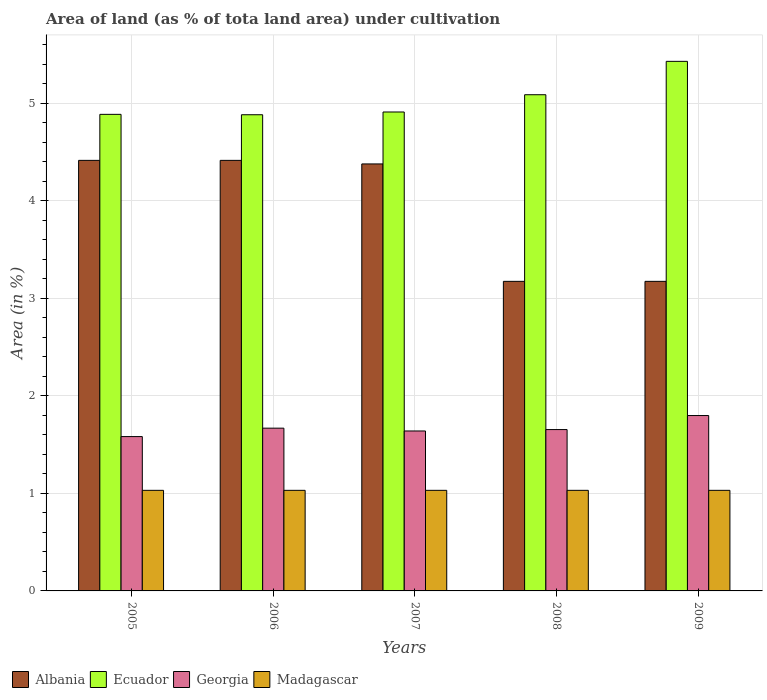How many different coloured bars are there?
Your answer should be very brief. 4. How many groups of bars are there?
Offer a terse response. 5. How many bars are there on the 5th tick from the left?
Your answer should be compact. 4. How many bars are there on the 1st tick from the right?
Your answer should be compact. 4. In how many cases, is the number of bars for a given year not equal to the number of legend labels?
Your answer should be very brief. 0. What is the percentage of land under cultivation in Georgia in 2009?
Offer a terse response. 1.8. Across all years, what is the maximum percentage of land under cultivation in Madagascar?
Ensure brevity in your answer.  1.03. Across all years, what is the minimum percentage of land under cultivation in Ecuador?
Ensure brevity in your answer.  4.88. In which year was the percentage of land under cultivation in Albania minimum?
Your answer should be compact. 2008. What is the total percentage of land under cultivation in Georgia in the graph?
Keep it short and to the point. 8.35. What is the difference between the percentage of land under cultivation in Albania in 2005 and that in 2009?
Give a very brief answer. 1.24. What is the difference between the percentage of land under cultivation in Georgia in 2009 and the percentage of land under cultivation in Albania in 2006?
Keep it short and to the point. -2.62. What is the average percentage of land under cultivation in Madagascar per year?
Provide a short and direct response. 1.03. In the year 2007, what is the difference between the percentage of land under cultivation in Georgia and percentage of land under cultivation in Ecuador?
Offer a very short reply. -3.27. What is the difference between the highest and the lowest percentage of land under cultivation in Albania?
Offer a terse response. 1.24. Is it the case that in every year, the sum of the percentage of land under cultivation in Ecuador and percentage of land under cultivation in Georgia is greater than the sum of percentage of land under cultivation in Madagascar and percentage of land under cultivation in Albania?
Your answer should be very brief. No. What does the 3rd bar from the left in 2009 represents?
Provide a short and direct response. Georgia. What does the 4th bar from the right in 2006 represents?
Your response must be concise. Albania. Is it the case that in every year, the sum of the percentage of land under cultivation in Madagascar and percentage of land under cultivation in Albania is greater than the percentage of land under cultivation in Ecuador?
Give a very brief answer. No. Are all the bars in the graph horizontal?
Offer a terse response. No. How many years are there in the graph?
Offer a terse response. 5. Are the values on the major ticks of Y-axis written in scientific E-notation?
Your answer should be compact. No. Does the graph contain any zero values?
Offer a very short reply. No. Does the graph contain grids?
Keep it short and to the point. Yes. How many legend labels are there?
Give a very brief answer. 4. What is the title of the graph?
Make the answer very short. Area of land (as % of tota land area) under cultivation. Does "Cyprus" appear as one of the legend labels in the graph?
Make the answer very short. No. What is the label or title of the Y-axis?
Give a very brief answer. Area (in %). What is the Area (in %) in Albania in 2005?
Make the answer very short. 4.42. What is the Area (in %) in Ecuador in 2005?
Provide a succinct answer. 4.89. What is the Area (in %) in Georgia in 2005?
Your response must be concise. 1.58. What is the Area (in %) of Madagascar in 2005?
Provide a short and direct response. 1.03. What is the Area (in %) in Albania in 2006?
Your answer should be compact. 4.42. What is the Area (in %) in Ecuador in 2006?
Give a very brief answer. 4.88. What is the Area (in %) of Georgia in 2006?
Provide a succinct answer. 1.67. What is the Area (in %) in Madagascar in 2006?
Your response must be concise. 1.03. What is the Area (in %) of Albania in 2007?
Your response must be concise. 4.38. What is the Area (in %) of Ecuador in 2007?
Provide a succinct answer. 4.91. What is the Area (in %) in Georgia in 2007?
Your response must be concise. 1.64. What is the Area (in %) in Madagascar in 2007?
Your answer should be very brief. 1.03. What is the Area (in %) in Albania in 2008?
Your answer should be very brief. 3.18. What is the Area (in %) of Ecuador in 2008?
Your answer should be very brief. 5.09. What is the Area (in %) in Georgia in 2008?
Your response must be concise. 1.65. What is the Area (in %) in Madagascar in 2008?
Your answer should be very brief. 1.03. What is the Area (in %) of Albania in 2009?
Offer a very short reply. 3.18. What is the Area (in %) of Ecuador in 2009?
Offer a terse response. 5.43. What is the Area (in %) in Georgia in 2009?
Your response must be concise. 1.8. What is the Area (in %) in Madagascar in 2009?
Ensure brevity in your answer.  1.03. Across all years, what is the maximum Area (in %) of Albania?
Provide a succinct answer. 4.42. Across all years, what is the maximum Area (in %) in Ecuador?
Provide a succinct answer. 5.43. Across all years, what is the maximum Area (in %) in Georgia?
Ensure brevity in your answer.  1.8. Across all years, what is the maximum Area (in %) of Madagascar?
Your response must be concise. 1.03. Across all years, what is the minimum Area (in %) of Albania?
Keep it short and to the point. 3.18. Across all years, what is the minimum Area (in %) of Ecuador?
Provide a short and direct response. 4.88. Across all years, what is the minimum Area (in %) in Georgia?
Provide a short and direct response. 1.58. Across all years, what is the minimum Area (in %) in Madagascar?
Offer a very short reply. 1.03. What is the total Area (in %) of Albania in the graph?
Ensure brevity in your answer.  19.56. What is the total Area (in %) in Ecuador in the graph?
Keep it short and to the point. 25.21. What is the total Area (in %) of Georgia in the graph?
Your answer should be very brief. 8.35. What is the total Area (in %) of Madagascar in the graph?
Your response must be concise. 5.16. What is the difference between the Area (in %) in Albania in 2005 and that in 2006?
Your answer should be compact. 0. What is the difference between the Area (in %) of Ecuador in 2005 and that in 2006?
Ensure brevity in your answer.  0. What is the difference between the Area (in %) of Georgia in 2005 and that in 2006?
Provide a succinct answer. -0.09. What is the difference between the Area (in %) in Madagascar in 2005 and that in 2006?
Offer a very short reply. 0. What is the difference between the Area (in %) in Albania in 2005 and that in 2007?
Provide a succinct answer. 0.04. What is the difference between the Area (in %) of Ecuador in 2005 and that in 2007?
Provide a succinct answer. -0.02. What is the difference between the Area (in %) in Georgia in 2005 and that in 2007?
Offer a very short reply. -0.06. What is the difference between the Area (in %) of Albania in 2005 and that in 2008?
Offer a terse response. 1.24. What is the difference between the Area (in %) in Ecuador in 2005 and that in 2008?
Offer a very short reply. -0.2. What is the difference between the Area (in %) in Georgia in 2005 and that in 2008?
Your answer should be very brief. -0.07. What is the difference between the Area (in %) of Madagascar in 2005 and that in 2008?
Offer a terse response. 0. What is the difference between the Area (in %) of Albania in 2005 and that in 2009?
Give a very brief answer. 1.24. What is the difference between the Area (in %) in Ecuador in 2005 and that in 2009?
Your answer should be very brief. -0.54. What is the difference between the Area (in %) in Georgia in 2005 and that in 2009?
Give a very brief answer. -0.22. What is the difference between the Area (in %) in Madagascar in 2005 and that in 2009?
Give a very brief answer. 0. What is the difference between the Area (in %) of Albania in 2006 and that in 2007?
Your answer should be compact. 0.04. What is the difference between the Area (in %) in Ecuador in 2006 and that in 2007?
Offer a terse response. -0.03. What is the difference between the Area (in %) of Georgia in 2006 and that in 2007?
Offer a terse response. 0.03. What is the difference between the Area (in %) of Albania in 2006 and that in 2008?
Give a very brief answer. 1.24. What is the difference between the Area (in %) of Ecuador in 2006 and that in 2008?
Your answer should be compact. -0.21. What is the difference between the Area (in %) of Georgia in 2006 and that in 2008?
Offer a terse response. 0.01. What is the difference between the Area (in %) in Madagascar in 2006 and that in 2008?
Provide a short and direct response. 0. What is the difference between the Area (in %) of Albania in 2006 and that in 2009?
Keep it short and to the point. 1.24. What is the difference between the Area (in %) of Ecuador in 2006 and that in 2009?
Provide a short and direct response. -0.55. What is the difference between the Area (in %) of Georgia in 2006 and that in 2009?
Ensure brevity in your answer.  -0.13. What is the difference between the Area (in %) of Madagascar in 2006 and that in 2009?
Your answer should be compact. 0. What is the difference between the Area (in %) of Albania in 2007 and that in 2008?
Provide a succinct answer. 1.2. What is the difference between the Area (in %) of Ecuador in 2007 and that in 2008?
Offer a terse response. -0.18. What is the difference between the Area (in %) of Georgia in 2007 and that in 2008?
Make the answer very short. -0.01. What is the difference between the Area (in %) in Madagascar in 2007 and that in 2008?
Give a very brief answer. 0. What is the difference between the Area (in %) of Albania in 2007 and that in 2009?
Ensure brevity in your answer.  1.2. What is the difference between the Area (in %) of Ecuador in 2007 and that in 2009?
Make the answer very short. -0.52. What is the difference between the Area (in %) of Georgia in 2007 and that in 2009?
Keep it short and to the point. -0.16. What is the difference between the Area (in %) of Madagascar in 2007 and that in 2009?
Keep it short and to the point. 0. What is the difference between the Area (in %) of Albania in 2008 and that in 2009?
Your answer should be compact. 0. What is the difference between the Area (in %) in Ecuador in 2008 and that in 2009?
Your answer should be very brief. -0.34. What is the difference between the Area (in %) in Georgia in 2008 and that in 2009?
Your answer should be compact. -0.14. What is the difference between the Area (in %) in Madagascar in 2008 and that in 2009?
Provide a succinct answer. 0. What is the difference between the Area (in %) of Albania in 2005 and the Area (in %) of Ecuador in 2006?
Make the answer very short. -0.47. What is the difference between the Area (in %) in Albania in 2005 and the Area (in %) in Georgia in 2006?
Offer a terse response. 2.75. What is the difference between the Area (in %) of Albania in 2005 and the Area (in %) of Madagascar in 2006?
Provide a succinct answer. 3.38. What is the difference between the Area (in %) of Ecuador in 2005 and the Area (in %) of Georgia in 2006?
Make the answer very short. 3.22. What is the difference between the Area (in %) in Ecuador in 2005 and the Area (in %) in Madagascar in 2006?
Provide a succinct answer. 3.86. What is the difference between the Area (in %) in Georgia in 2005 and the Area (in %) in Madagascar in 2006?
Give a very brief answer. 0.55. What is the difference between the Area (in %) in Albania in 2005 and the Area (in %) in Ecuador in 2007?
Offer a terse response. -0.5. What is the difference between the Area (in %) in Albania in 2005 and the Area (in %) in Georgia in 2007?
Provide a succinct answer. 2.78. What is the difference between the Area (in %) in Albania in 2005 and the Area (in %) in Madagascar in 2007?
Provide a succinct answer. 3.38. What is the difference between the Area (in %) in Ecuador in 2005 and the Area (in %) in Georgia in 2007?
Make the answer very short. 3.25. What is the difference between the Area (in %) in Ecuador in 2005 and the Area (in %) in Madagascar in 2007?
Offer a very short reply. 3.86. What is the difference between the Area (in %) of Georgia in 2005 and the Area (in %) of Madagascar in 2007?
Provide a short and direct response. 0.55. What is the difference between the Area (in %) of Albania in 2005 and the Area (in %) of Ecuador in 2008?
Give a very brief answer. -0.67. What is the difference between the Area (in %) of Albania in 2005 and the Area (in %) of Georgia in 2008?
Make the answer very short. 2.76. What is the difference between the Area (in %) of Albania in 2005 and the Area (in %) of Madagascar in 2008?
Your answer should be compact. 3.38. What is the difference between the Area (in %) of Ecuador in 2005 and the Area (in %) of Georgia in 2008?
Make the answer very short. 3.23. What is the difference between the Area (in %) of Ecuador in 2005 and the Area (in %) of Madagascar in 2008?
Provide a succinct answer. 3.86. What is the difference between the Area (in %) of Georgia in 2005 and the Area (in %) of Madagascar in 2008?
Ensure brevity in your answer.  0.55. What is the difference between the Area (in %) of Albania in 2005 and the Area (in %) of Ecuador in 2009?
Your answer should be compact. -1.02. What is the difference between the Area (in %) in Albania in 2005 and the Area (in %) in Georgia in 2009?
Offer a very short reply. 2.62. What is the difference between the Area (in %) of Albania in 2005 and the Area (in %) of Madagascar in 2009?
Offer a terse response. 3.38. What is the difference between the Area (in %) of Ecuador in 2005 and the Area (in %) of Georgia in 2009?
Provide a succinct answer. 3.09. What is the difference between the Area (in %) of Ecuador in 2005 and the Area (in %) of Madagascar in 2009?
Keep it short and to the point. 3.86. What is the difference between the Area (in %) of Georgia in 2005 and the Area (in %) of Madagascar in 2009?
Keep it short and to the point. 0.55. What is the difference between the Area (in %) of Albania in 2006 and the Area (in %) of Ecuador in 2007?
Your answer should be compact. -0.5. What is the difference between the Area (in %) of Albania in 2006 and the Area (in %) of Georgia in 2007?
Keep it short and to the point. 2.78. What is the difference between the Area (in %) of Albania in 2006 and the Area (in %) of Madagascar in 2007?
Provide a short and direct response. 3.38. What is the difference between the Area (in %) of Ecuador in 2006 and the Area (in %) of Georgia in 2007?
Make the answer very short. 3.24. What is the difference between the Area (in %) in Ecuador in 2006 and the Area (in %) in Madagascar in 2007?
Provide a succinct answer. 3.85. What is the difference between the Area (in %) of Georgia in 2006 and the Area (in %) of Madagascar in 2007?
Give a very brief answer. 0.64. What is the difference between the Area (in %) in Albania in 2006 and the Area (in %) in Ecuador in 2008?
Provide a short and direct response. -0.67. What is the difference between the Area (in %) in Albania in 2006 and the Area (in %) in Georgia in 2008?
Give a very brief answer. 2.76. What is the difference between the Area (in %) in Albania in 2006 and the Area (in %) in Madagascar in 2008?
Your answer should be very brief. 3.38. What is the difference between the Area (in %) in Ecuador in 2006 and the Area (in %) in Georgia in 2008?
Offer a terse response. 3.23. What is the difference between the Area (in %) in Ecuador in 2006 and the Area (in %) in Madagascar in 2008?
Your response must be concise. 3.85. What is the difference between the Area (in %) in Georgia in 2006 and the Area (in %) in Madagascar in 2008?
Your response must be concise. 0.64. What is the difference between the Area (in %) of Albania in 2006 and the Area (in %) of Ecuador in 2009?
Your answer should be compact. -1.02. What is the difference between the Area (in %) in Albania in 2006 and the Area (in %) in Georgia in 2009?
Ensure brevity in your answer.  2.62. What is the difference between the Area (in %) in Albania in 2006 and the Area (in %) in Madagascar in 2009?
Keep it short and to the point. 3.38. What is the difference between the Area (in %) in Ecuador in 2006 and the Area (in %) in Georgia in 2009?
Offer a terse response. 3.09. What is the difference between the Area (in %) in Ecuador in 2006 and the Area (in %) in Madagascar in 2009?
Your answer should be compact. 3.85. What is the difference between the Area (in %) of Georgia in 2006 and the Area (in %) of Madagascar in 2009?
Provide a short and direct response. 0.64. What is the difference between the Area (in %) of Albania in 2007 and the Area (in %) of Ecuador in 2008?
Your answer should be compact. -0.71. What is the difference between the Area (in %) of Albania in 2007 and the Area (in %) of Georgia in 2008?
Offer a very short reply. 2.72. What is the difference between the Area (in %) of Albania in 2007 and the Area (in %) of Madagascar in 2008?
Your response must be concise. 3.35. What is the difference between the Area (in %) in Ecuador in 2007 and the Area (in %) in Georgia in 2008?
Offer a terse response. 3.26. What is the difference between the Area (in %) of Ecuador in 2007 and the Area (in %) of Madagascar in 2008?
Offer a very short reply. 3.88. What is the difference between the Area (in %) in Georgia in 2007 and the Area (in %) in Madagascar in 2008?
Your response must be concise. 0.61. What is the difference between the Area (in %) of Albania in 2007 and the Area (in %) of Ecuador in 2009?
Offer a very short reply. -1.05. What is the difference between the Area (in %) in Albania in 2007 and the Area (in %) in Georgia in 2009?
Give a very brief answer. 2.58. What is the difference between the Area (in %) in Albania in 2007 and the Area (in %) in Madagascar in 2009?
Your answer should be compact. 3.35. What is the difference between the Area (in %) in Ecuador in 2007 and the Area (in %) in Georgia in 2009?
Keep it short and to the point. 3.11. What is the difference between the Area (in %) in Ecuador in 2007 and the Area (in %) in Madagascar in 2009?
Offer a very short reply. 3.88. What is the difference between the Area (in %) in Georgia in 2007 and the Area (in %) in Madagascar in 2009?
Offer a very short reply. 0.61. What is the difference between the Area (in %) in Albania in 2008 and the Area (in %) in Ecuador in 2009?
Your response must be concise. -2.26. What is the difference between the Area (in %) of Albania in 2008 and the Area (in %) of Georgia in 2009?
Give a very brief answer. 1.38. What is the difference between the Area (in %) in Albania in 2008 and the Area (in %) in Madagascar in 2009?
Your response must be concise. 2.14. What is the difference between the Area (in %) of Ecuador in 2008 and the Area (in %) of Georgia in 2009?
Your answer should be very brief. 3.29. What is the difference between the Area (in %) of Ecuador in 2008 and the Area (in %) of Madagascar in 2009?
Your response must be concise. 4.06. What is the difference between the Area (in %) of Georgia in 2008 and the Area (in %) of Madagascar in 2009?
Offer a terse response. 0.62. What is the average Area (in %) of Albania per year?
Provide a short and direct response. 3.91. What is the average Area (in %) of Ecuador per year?
Offer a very short reply. 5.04. What is the average Area (in %) in Georgia per year?
Your answer should be compact. 1.67. What is the average Area (in %) in Madagascar per year?
Your answer should be compact. 1.03. In the year 2005, what is the difference between the Area (in %) of Albania and Area (in %) of Ecuador?
Give a very brief answer. -0.47. In the year 2005, what is the difference between the Area (in %) in Albania and Area (in %) in Georgia?
Offer a very short reply. 2.83. In the year 2005, what is the difference between the Area (in %) of Albania and Area (in %) of Madagascar?
Your answer should be very brief. 3.38. In the year 2005, what is the difference between the Area (in %) in Ecuador and Area (in %) in Georgia?
Provide a short and direct response. 3.31. In the year 2005, what is the difference between the Area (in %) of Ecuador and Area (in %) of Madagascar?
Offer a terse response. 3.86. In the year 2005, what is the difference between the Area (in %) of Georgia and Area (in %) of Madagascar?
Make the answer very short. 0.55. In the year 2006, what is the difference between the Area (in %) of Albania and Area (in %) of Ecuador?
Keep it short and to the point. -0.47. In the year 2006, what is the difference between the Area (in %) of Albania and Area (in %) of Georgia?
Make the answer very short. 2.75. In the year 2006, what is the difference between the Area (in %) of Albania and Area (in %) of Madagascar?
Your answer should be compact. 3.38. In the year 2006, what is the difference between the Area (in %) in Ecuador and Area (in %) in Georgia?
Make the answer very short. 3.21. In the year 2006, what is the difference between the Area (in %) in Ecuador and Area (in %) in Madagascar?
Your answer should be very brief. 3.85. In the year 2006, what is the difference between the Area (in %) of Georgia and Area (in %) of Madagascar?
Ensure brevity in your answer.  0.64. In the year 2007, what is the difference between the Area (in %) in Albania and Area (in %) in Ecuador?
Your answer should be very brief. -0.53. In the year 2007, what is the difference between the Area (in %) in Albania and Area (in %) in Georgia?
Provide a short and direct response. 2.74. In the year 2007, what is the difference between the Area (in %) in Albania and Area (in %) in Madagascar?
Ensure brevity in your answer.  3.35. In the year 2007, what is the difference between the Area (in %) in Ecuador and Area (in %) in Georgia?
Provide a short and direct response. 3.27. In the year 2007, what is the difference between the Area (in %) of Ecuador and Area (in %) of Madagascar?
Provide a short and direct response. 3.88. In the year 2007, what is the difference between the Area (in %) in Georgia and Area (in %) in Madagascar?
Your response must be concise. 0.61. In the year 2008, what is the difference between the Area (in %) in Albania and Area (in %) in Ecuador?
Keep it short and to the point. -1.91. In the year 2008, what is the difference between the Area (in %) of Albania and Area (in %) of Georgia?
Ensure brevity in your answer.  1.52. In the year 2008, what is the difference between the Area (in %) in Albania and Area (in %) in Madagascar?
Your answer should be very brief. 2.14. In the year 2008, what is the difference between the Area (in %) in Ecuador and Area (in %) in Georgia?
Your answer should be compact. 3.43. In the year 2008, what is the difference between the Area (in %) in Ecuador and Area (in %) in Madagascar?
Offer a terse response. 4.06. In the year 2008, what is the difference between the Area (in %) in Georgia and Area (in %) in Madagascar?
Keep it short and to the point. 0.62. In the year 2009, what is the difference between the Area (in %) in Albania and Area (in %) in Ecuador?
Offer a very short reply. -2.26. In the year 2009, what is the difference between the Area (in %) of Albania and Area (in %) of Georgia?
Your answer should be compact. 1.38. In the year 2009, what is the difference between the Area (in %) in Albania and Area (in %) in Madagascar?
Give a very brief answer. 2.14. In the year 2009, what is the difference between the Area (in %) of Ecuador and Area (in %) of Georgia?
Make the answer very short. 3.63. In the year 2009, what is the difference between the Area (in %) in Ecuador and Area (in %) in Madagascar?
Your response must be concise. 4.4. In the year 2009, what is the difference between the Area (in %) in Georgia and Area (in %) in Madagascar?
Your answer should be very brief. 0.77. What is the ratio of the Area (in %) of Albania in 2005 to that in 2006?
Your response must be concise. 1. What is the ratio of the Area (in %) in Ecuador in 2005 to that in 2006?
Offer a terse response. 1. What is the ratio of the Area (in %) in Georgia in 2005 to that in 2006?
Offer a terse response. 0.95. What is the ratio of the Area (in %) of Albania in 2005 to that in 2007?
Ensure brevity in your answer.  1.01. What is the ratio of the Area (in %) of Ecuador in 2005 to that in 2007?
Give a very brief answer. 1. What is the ratio of the Area (in %) in Georgia in 2005 to that in 2007?
Keep it short and to the point. 0.96. What is the ratio of the Area (in %) in Madagascar in 2005 to that in 2007?
Your answer should be compact. 1. What is the ratio of the Area (in %) in Albania in 2005 to that in 2008?
Offer a terse response. 1.39. What is the ratio of the Area (in %) in Ecuador in 2005 to that in 2008?
Offer a very short reply. 0.96. What is the ratio of the Area (in %) of Georgia in 2005 to that in 2008?
Make the answer very short. 0.96. What is the ratio of the Area (in %) of Albania in 2005 to that in 2009?
Provide a short and direct response. 1.39. What is the ratio of the Area (in %) in Ecuador in 2005 to that in 2009?
Ensure brevity in your answer.  0.9. What is the ratio of the Area (in %) in Georgia in 2005 to that in 2009?
Give a very brief answer. 0.88. What is the ratio of the Area (in %) of Madagascar in 2005 to that in 2009?
Provide a succinct answer. 1. What is the ratio of the Area (in %) in Albania in 2006 to that in 2007?
Give a very brief answer. 1.01. What is the ratio of the Area (in %) in Ecuador in 2006 to that in 2007?
Ensure brevity in your answer.  0.99. What is the ratio of the Area (in %) of Georgia in 2006 to that in 2007?
Offer a terse response. 1.02. What is the ratio of the Area (in %) in Madagascar in 2006 to that in 2007?
Your response must be concise. 1. What is the ratio of the Area (in %) of Albania in 2006 to that in 2008?
Ensure brevity in your answer.  1.39. What is the ratio of the Area (in %) in Ecuador in 2006 to that in 2008?
Offer a very short reply. 0.96. What is the ratio of the Area (in %) in Georgia in 2006 to that in 2008?
Provide a succinct answer. 1.01. What is the ratio of the Area (in %) of Madagascar in 2006 to that in 2008?
Provide a succinct answer. 1. What is the ratio of the Area (in %) of Albania in 2006 to that in 2009?
Provide a short and direct response. 1.39. What is the ratio of the Area (in %) in Ecuador in 2006 to that in 2009?
Ensure brevity in your answer.  0.9. What is the ratio of the Area (in %) in Georgia in 2006 to that in 2009?
Make the answer very short. 0.93. What is the ratio of the Area (in %) of Albania in 2007 to that in 2008?
Ensure brevity in your answer.  1.38. What is the ratio of the Area (in %) in Ecuador in 2007 to that in 2008?
Provide a short and direct response. 0.97. What is the ratio of the Area (in %) of Georgia in 2007 to that in 2008?
Give a very brief answer. 0.99. What is the ratio of the Area (in %) in Albania in 2007 to that in 2009?
Provide a succinct answer. 1.38. What is the ratio of the Area (in %) in Ecuador in 2007 to that in 2009?
Make the answer very short. 0.9. What is the ratio of the Area (in %) of Georgia in 2007 to that in 2009?
Your response must be concise. 0.91. What is the ratio of the Area (in %) in Ecuador in 2008 to that in 2009?
Your answer should be very brief. 0.94. What is the difference between the highest and the second highest Area (in %) of Albania?
Offer a terse response. 0. What is the difference between the highest and the second highest Area (in %) of Ecuador?
Make the answer very short. 0.34. What is the difference between the highest and the second highest Area (in %) of Georgia?
Ensure brevity in your answer.  0.13. What is the difference between the highest and the second highest Area (in %) of Madagascar?
Offer a terse response. 0. What is the difference between the highest and the lowest Area (in %) of Albania?
Your answer should be compact. 1.24. What is the difference between the highest and the lowest Area (in %) of Ecuador?
Provide a succinct answer. 0.55. What is the difference between the highest and the lowest Area (in %) in Georgia?
Provide a succinct answer. 0.22. 